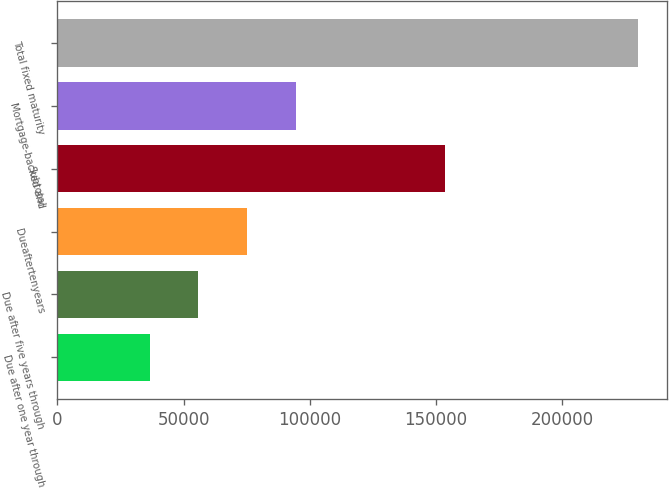Convert chart to OTSL. <chart><loc_0><loc_0><loc_500><loc_500><bar_chart><fcel>Due after one year through<fcel>Due after five years through<fcel>Dueaftertenyears<fcel>Subtotal<fcel>Mortgage-backed and<fcel>Total fixed maturity<nl><fcel>36562<fcel>55910.8<fcel>75259.6<fcel>153533<fcel>94608.4<fcel>230050<nl></chart> 